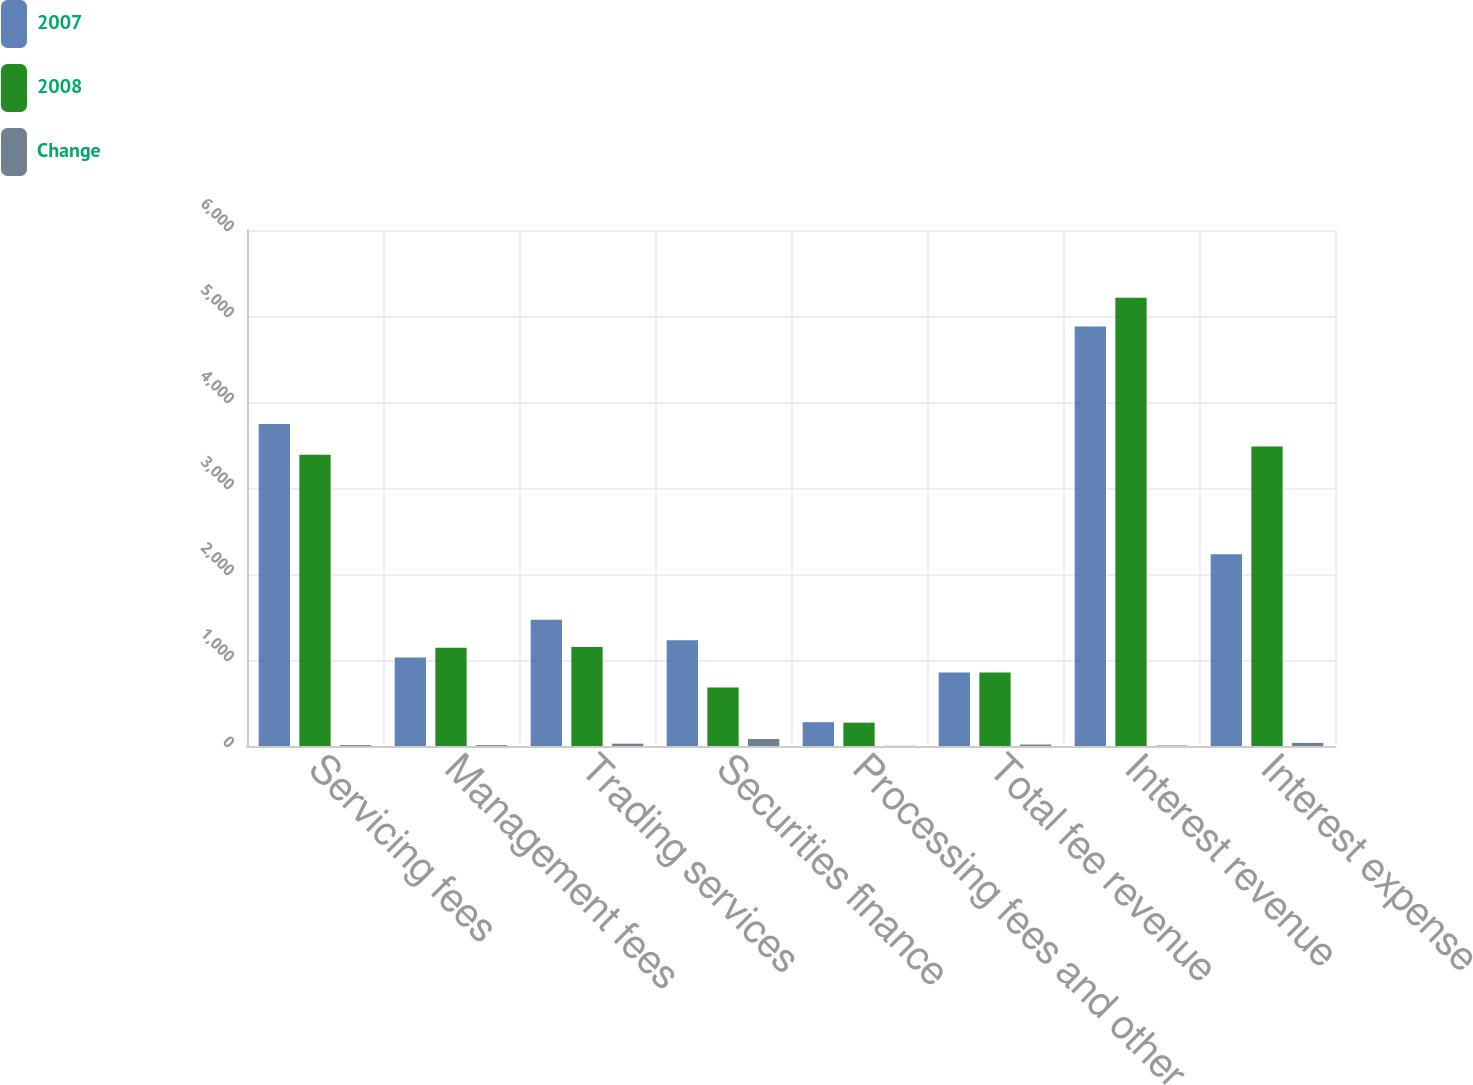<chart> <loc_0><loc_0><loc_500><loc_500><stacked_bar_chart><ecel><fcel>Servicing fees<fcel>Management fees<fcel>Trading services<fcel>Securities finance<fcel>Processing fees and other<fcel>Total fee revenue<fcel>Interest revenue<fcel>Interest expense<nl><fcel>2007<fcel>3745<fcel>1028<fcel>1467<fcel>1230<fcel>277<fcel>854.5<fcel>4879<fcel>2229<nl><fcel>2008<fcel>3388<fcel>1141<fcel>1152<fcel>681<fcel>271<fcel>854.5<fcel>5212<fcel>3482<nl><fcel>Change<fcel>11<fcel>10<fcel>27<fcel>81<fcel>2<fcel>17<fcel>6<fcel>36<nl></chart> 